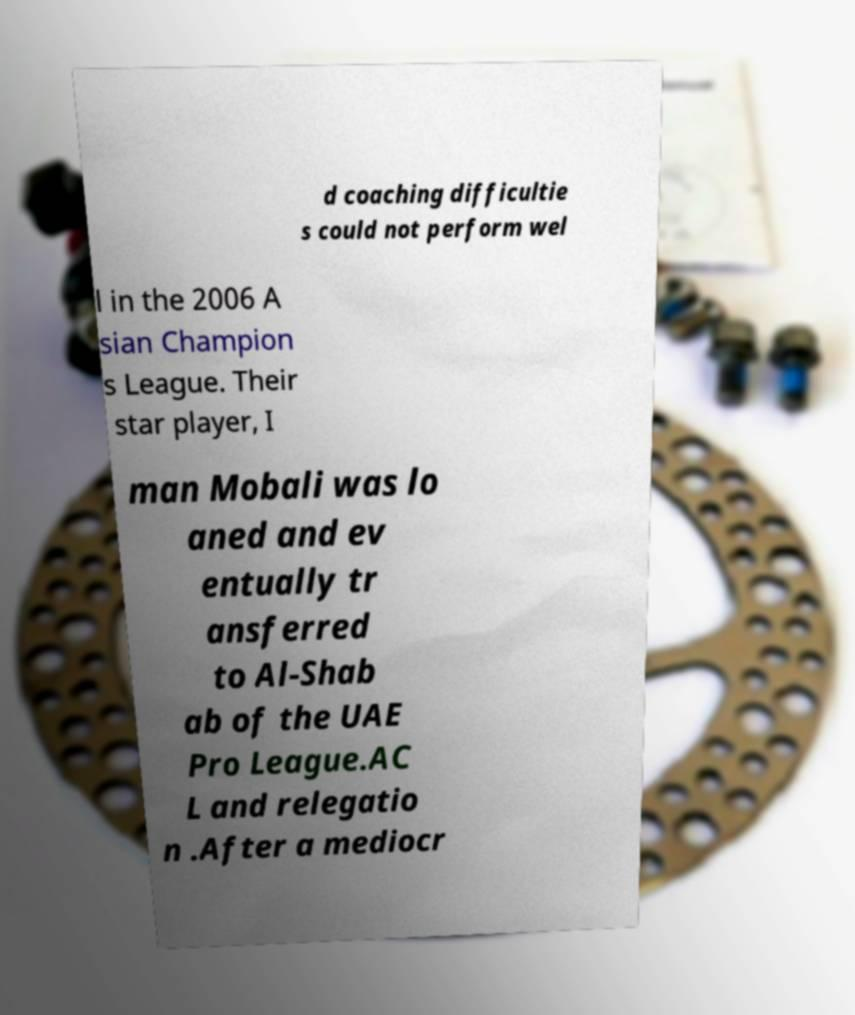Could you extract and type out the text from this image? d coaching difficultie s could not perform wel l in the 2006 A sian Champion s League. Their star player, I man Mobali was lo aned and ev entually tr ansferred to Al-Shab ab of the UAE Pro League.AC L and relegatio n .After a mediocr 